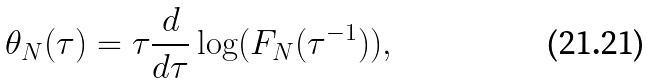<formula> <loc_0><loc_0><loc_500><loc_500>\theta _ { N } ( \tau ) = \tau \frac { d } { d \tau } \log ( F _ { N } ( \tau ^ { - 1 } ) ) ,</formula> 